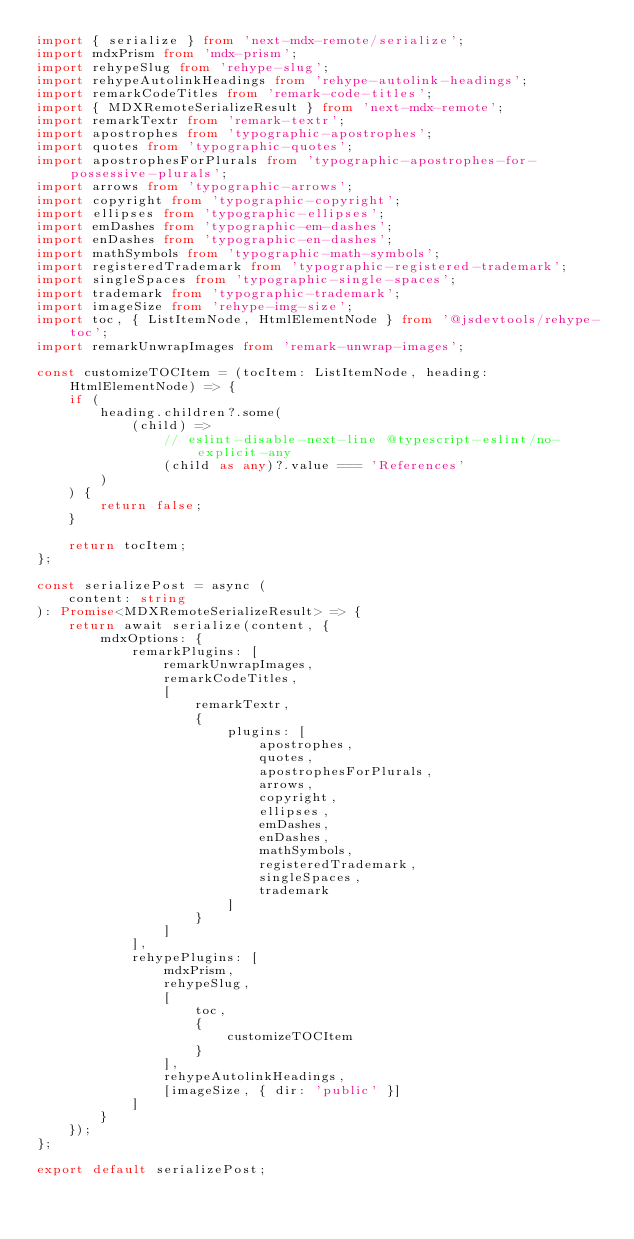Convert code to text. <code><loc_0><loc_0><loc_500><loc_500><_TypeScript_>import { serialize } from 'next-mdx-remote/serialize';
import mdxPrism from 'mdx-prism';
import rehypeSlug from 'rehype-slug';
import rehypeAutolinkHeadings from 'rehype-autolink-headings';
import remarkCodeTitles from 'remark-code-titles';
import { MDXRemoteSerializeResult } from 'next-mdx-remote';
import remarkTextr from 'remark-textr';
import apostrophes from 'typographic-apostrophes';
import quotes from 'typographic-quotes';
import apostrophesForPlurals from 'typographic-apostrophes-for-possessive-plurals';
import arrows from 'typographic-arrows';
import copyright from 'typographic-copyright';
import ellipses from 'typographic-ellipses';
import emDashes from 'typographic-em-dashes';
import enDashes from 'typographic-en-dashes';
import mathSymbols from 'typographic-math-symbols';
import registeredTrademark from 'typographic-registered-trademark';
import singleSpaces from 'typographic-single-spaces';
import trademark from 'typographic-trademark';
import imageSize from 'rehype-img-size';
import toc, { ListItemNode, HtmlElementNode } from '@jsdevtools/rehype-toc';
import remarkUnwrapImages from 'remark-unwrap-images';

const customizeTOCItem = (tocItem: ListItemNode, heading: HtmlElementNode) => {
    if (
        heading.children?.some(
            (child) =>
                // eslint-disable-next-line @typescript-eslint/no-explicit-any
                (child as any)?.value === 'References'
        )
    ) {
        return false;
    }

    return tocItem;
};

const serializePost = async (
    content: string
): Promise<MDXRemoteSerializeResult> => {
    return await serialize(content, {
        mdxOptions: {
            remarkPlugins: [
                remarkUnwrapImages,
                remarkCodeTitles,
                [
                    remarkTextr,
                    {
                        plugins: [
                            apostrophes,
                            quotes,
                            apostrophesForPlurals,
                            arrows,
                            copyright,
                            ellipses,
                            emDashes,
                            enDashes,
                            mathSymbols,
                            registeredTrademark,
                            singleSpaces,
                            trademark
                        ]
                    }
                ]
            ],
            rehypePlugins: [
                mdxPrism,
                rehypeSlug,
                [
                    toc,
                    {
                        customizeTOCItem
                    }
                ],
                rehypeAutolinkHeadings,
                [imageSize, { dir: 'public' }]
            ]
        }
    });
};

export default serializePost;
</code> 